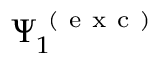Convert formula to latex. <formula><loc_0><loc_0><loc_500><loc_500>\Psi _ { 1 } ^ { ( e x c ) }</formula> 